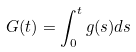<formula> <loc_0><loc_0><loc_500><loc_500>G ( t ) = \int _ { 0 } ^ { t } g ( s ) d s</formula> 